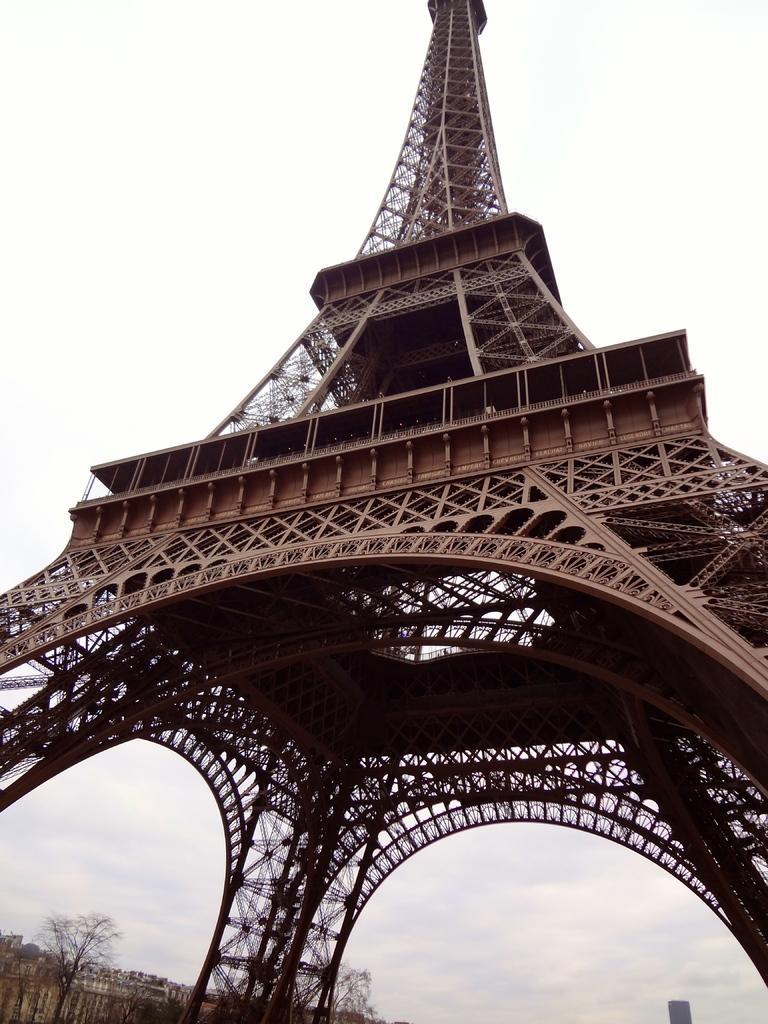Describe this image in one or two sentences. In this image, I can see an Eiffel Tower. At the bottom of the image, there are trees. In the background, I can see the sky. 